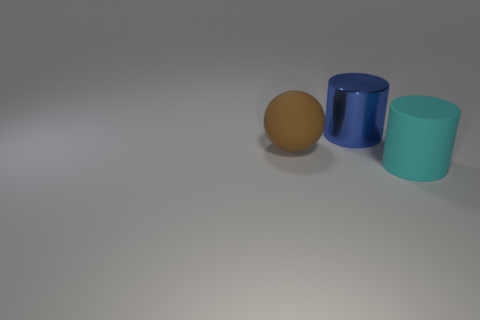How does the lighting in the image affect the mood or perception of the objects? The lighting in the image is soft and diffused, casting gentle shadows that provide a sense of calm and neutrality. There's no dramatic emphasis on any of the objects, which allows them to be perceived as they are, without any additional emotional context implied by the lighting. 